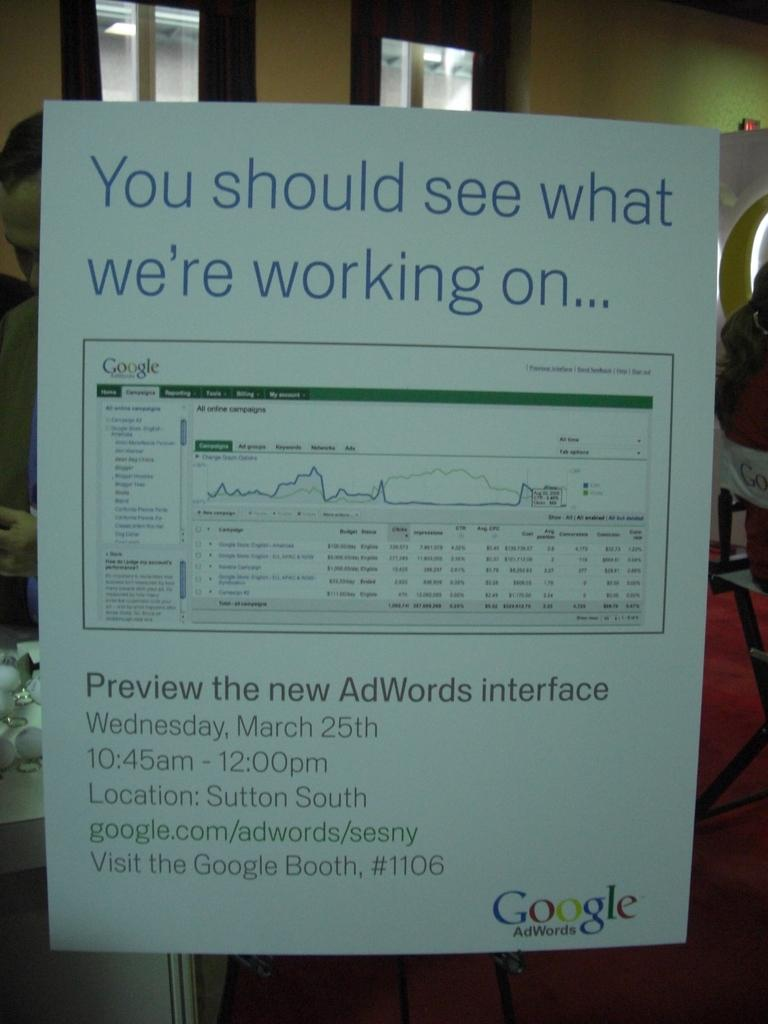<image>
Create a compact narrative representing the image presented. Paper posted on a wall that says "You should see what we're working on". 